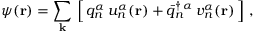<formula> <loc_0><loc_0><loc_500><loc_500>\psi ( { r } ) = \sum _ { k } \, \left [ \, q _ { n } ^ { \alpha } \, u _ { n } ^ { \alpha } ( { r } ) + { \bar { q } } _ { n } ^ { \dagger \, { \alpha } } \, v _ { n } ^ { \alpha } ( { r } ) \, \right ] \, ,</formula> 